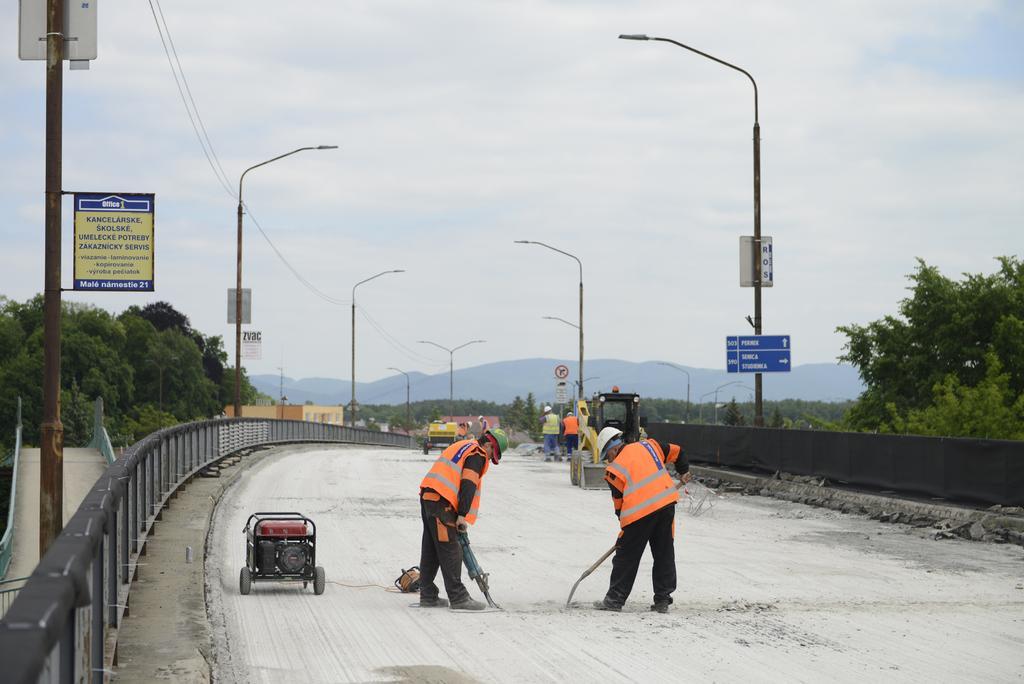Could you give a brief overview of what you see in this image? In this image in the foreground there are two people who are wearing helmets, and they are doing something and there is one vehicle like object. And at the bottom there is cement road, in the background there are some people, vehicles, poles, trees and some boards and there is a railing and fence. At the top of the image there is sky and also we could see some wires. 